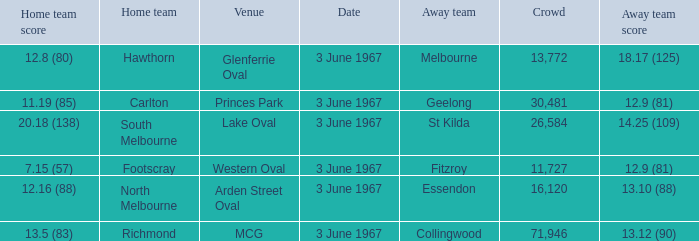Where did Geelong play as the away team? Princes Park. 